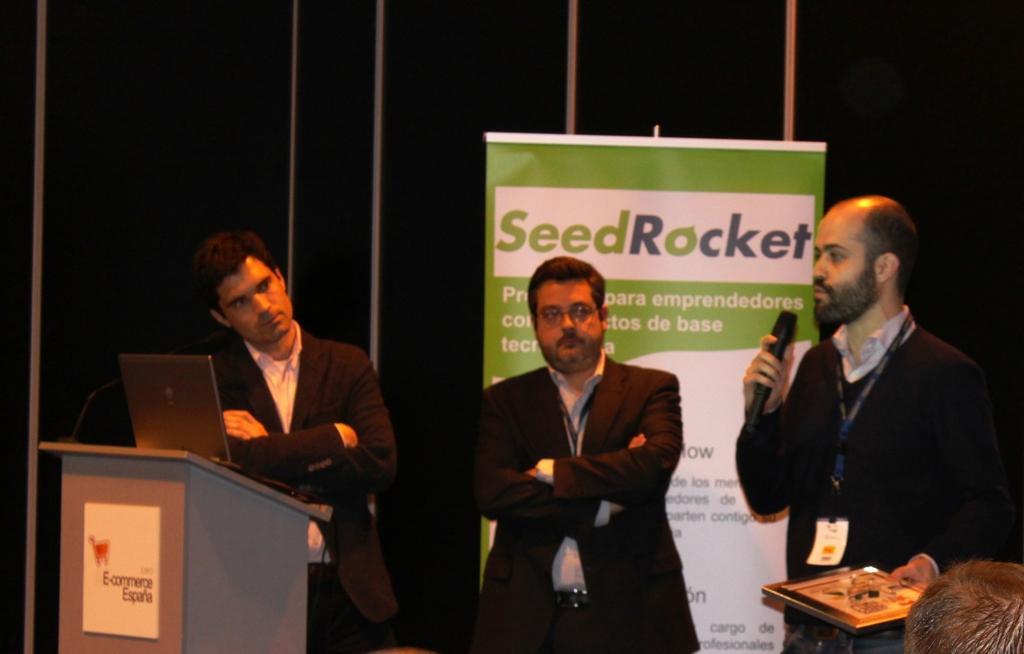How would you summarize this image in a sentence or two? This image consists of 3 persons. All of them are wearing blazers. There is a banner behind them. There is a podium on the left side. On that there is a laptop. The one who is on the right side is holding a mic. 